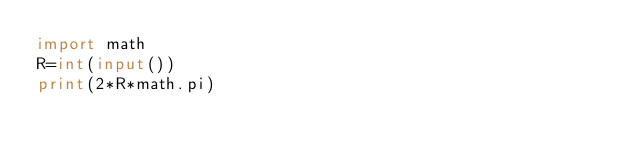Convert code to text. <code><loc_0><loc_0><loc_500><loc_500><_Python_>import math
R=int(input())
print(2*R*math.pi)</code> 